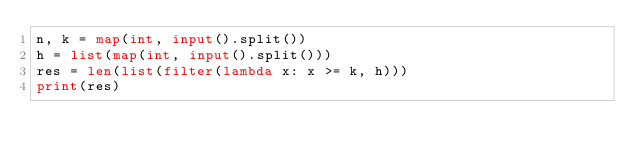Convert code to text. <code><loc_0><loc_0><loc_500><loc_500><_Python_>n, k = map(int, input().split())
h = list(map(int, input().split()))
res = len(list(filter(lambda x: x >= k, h)))
print(res)</code> 